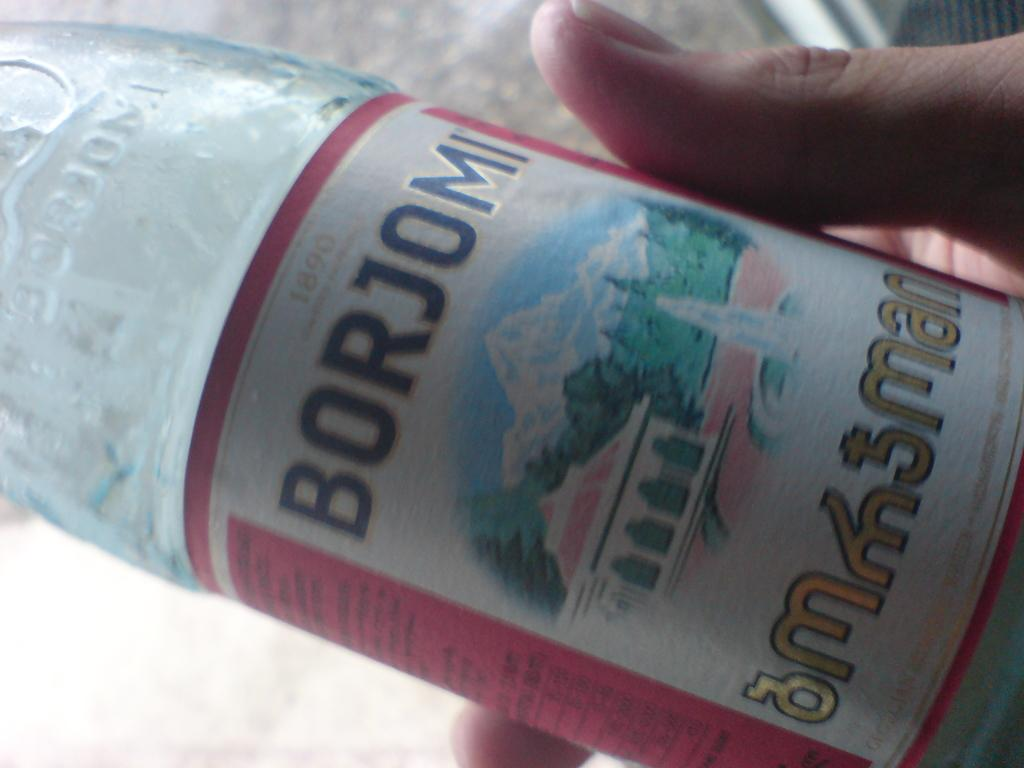What is the person's hand holding in the image? There is a person's hand holding a bottle in the image. What can be seen on the bottle? There is a sticker on the bottle. What is depicted on the sticker? The sticker features a building, mountains, and trees. What type of creature is sitting on the pan in the image? There is no pan or creature present in the image. 